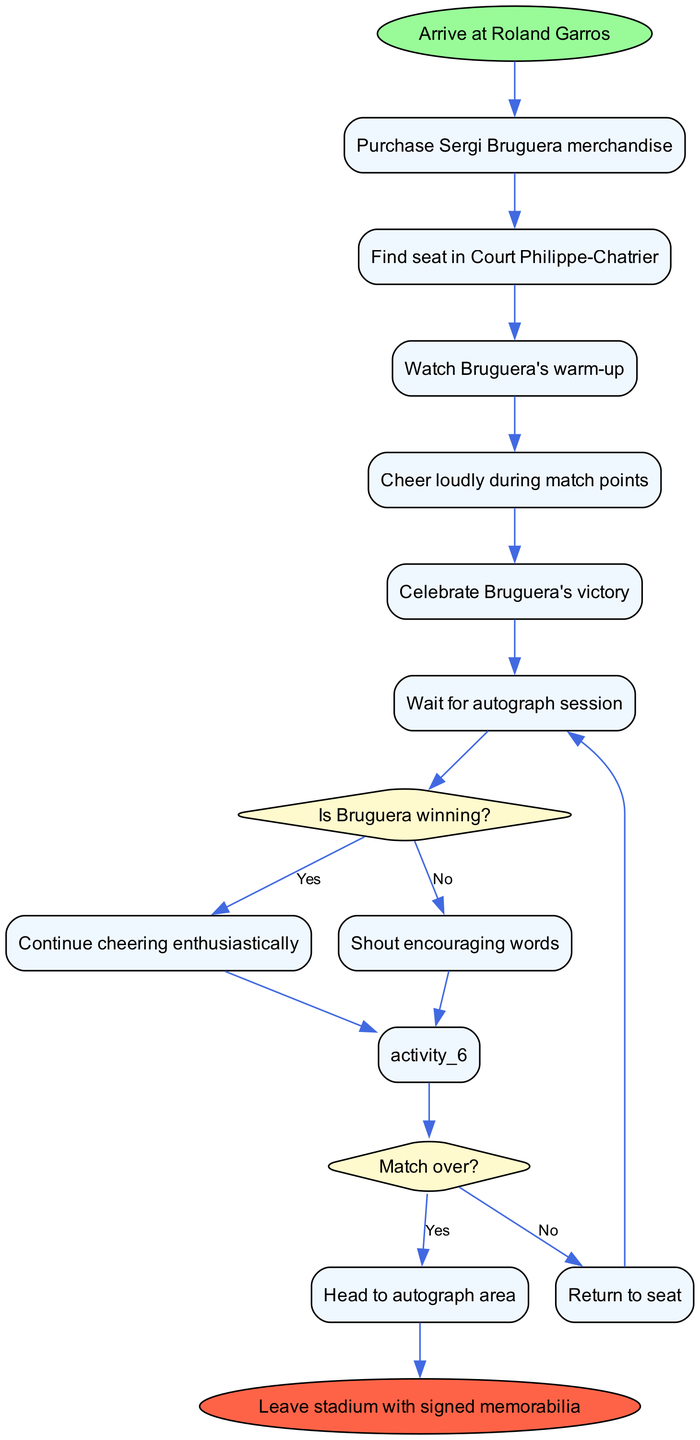What is the first activity after arriving at Roland Garros? The diagram shows that the first activity following the arrival at Roland Garros is the purchase of Sergi Bruguera merchandise. This is directly linked from the initial node.
Answer: Purchase Sergi Bruguera merchandise How many decision nodes are in the diagram? The diagram contains two decision nodes. Each decision node is represented by a diamond shape and is related to the events during the match, one concerning Bruguera's winning status and the other about the match's conclusion.
Answer: 2 What activity follows cheering loudly during match points if Bruguera is winning? If Bruguera is winning and the cheering leads to a decision, then the next step is to continue cheering enthusiastically. This is the "yes" path from the first decision node.
Answer: Continue cheering enthusiastically What happens when the match is over? According to the decision related to the match outcome, when it is over, the next step is to head to the autograph area. This is the "yes" response from the second decision node.
Answer: Head to autograph area Which merchandise will be purchased? The diagram mentions the purchase of Sergi Bruguera merchandise specifically, indicating that the focus is on items related to the player.
Answer: Sergi Bruguera merchandise What is the final action taken in the diagram? The final action taken as shown in the diagram is leaving the stadium with signed memorabilia. This is the conclusion of the specified activities.
Answer: Leave stadium with signed memorabilia 